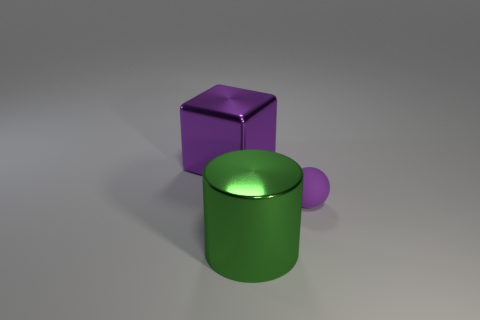Add 2 big yellow shiny balls. How many objects exist? 5 Subtract all blocks. How many objects are left? 2 Subtract all gray rubber blocks. Subtract all big things. How many objects are left? 1 Add 1 tiny purple matte balls. How many tiny purple matte balls are left? 2 Add 2 small yellow shiny objects. How many small yellow shiny objects exist? 2 Subtract 1 purple spheres. How many objects are left? 2 